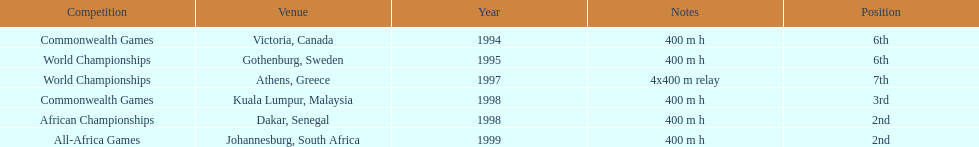What is the ultimate competition on the diagram? All-Africa Games. 